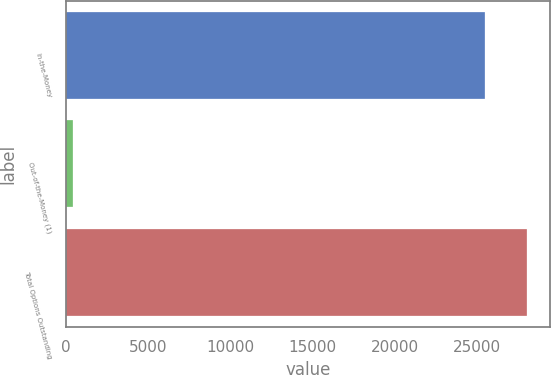Convert chart. <chart><loc_0><loc_0><loc_500><loc_500><bar_chart><fcel>In-the-Money<fcel>Out-of-the-Money (1)<fcel>Total Options Outstanding<nl><fcel>25467<fcel>457<fcel>28013.7<nl></chart> 